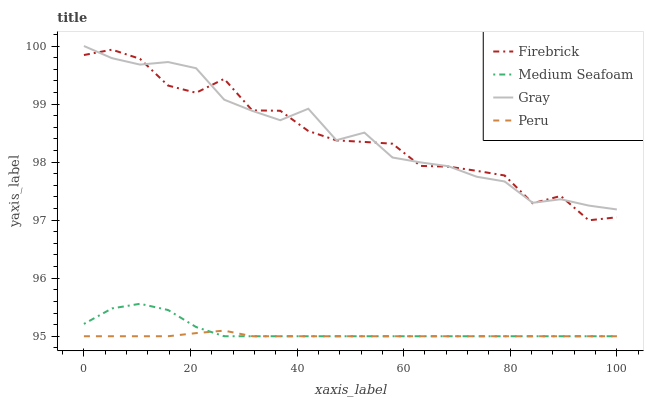Does Peru have the minimum area under the curve?
Answer yes or no. Yes. Does Gray have the maximum area under the curve?
Answer yes or no. Yes. Does Firebrick have the minimum area under the curve?
Answer yes or no. No. Does Firebrick have the maximum area under the curve?
Answer yes or no. No. Is Peru the smoothest?
Answer yes or no. Yes. Is Firebrick the roughest?
Answer yes or no. Yes. Is Medium Seafoam the smoothest?
Answer yes or no. No. Is Medium Seafoam the roughest?
Answer yes or no. No. Does Firebrick have the lowest value?
Answer yes or no. No. Does Gray have the highest value?
Answer yes or no. Yes. Does Firebrick have the highest value?
Answer yes or no. No. Is Medium Seafoam less than Gray?
Answer yes or no. Yes. Is Gray greater than Medium Seafoam?
Answer yes or no. Yes. Does Peru intersect Medium Seafoam?
Answer yes or no. Yes. Is Peru less than Medium Seafoam?
Answer yes or no. No. Is Peru greater than Medium Seafoam?
Answer yes or no. No. Does Medium Seafoam intersect Gray?
Answer yes or no. No. 